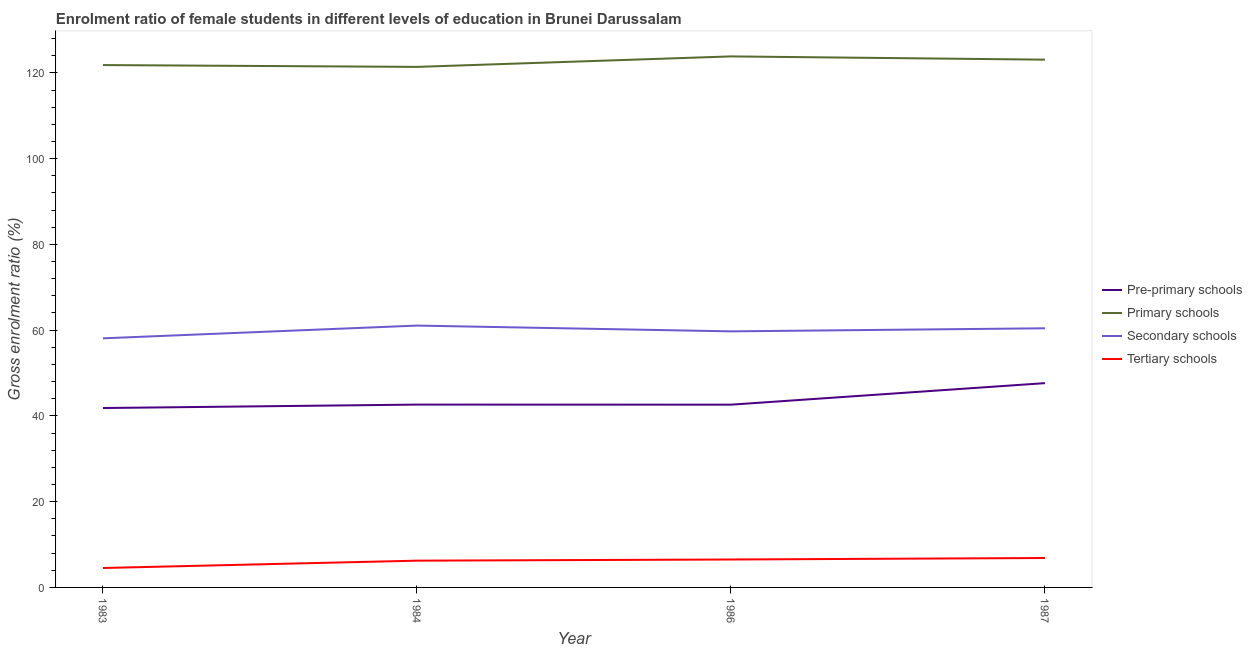What is the gross enrolment ratio(male) in tertiary schools in 1984?
Offer a terse response. 6.24. Across all years, what is the maximum gross enrolment ratio(male) in secondary schools?
Your response must be concise. 61.07. Across all years, what is the minimum gross enrolment ratio(male) in tertiary schools?
Your response must be concise. 4.53. In which year was the gross enrolment ratio(male) in tertiary schools minimum?
Your response must be concise. 1983. What is the total gross enrolment ratio(male) in pre-primary schools in the graph?
Offer a very short reply. 174.74. What is the difference between the gross enrolment ratio(male) in pre-primary schools in 1983 and that in 1986?
Your answer should be compact. -0.78. What is the difference between the gross enrolment ratio(male) in pre-primary schools in 1986 and the gross enrolment ratio(male) in tertiary schools in 1987?
Provide a succinct answer. 35.76. What is the average gross enrolment ratio(male) in pre-primary schools per year?
Ensure brevity in your answer.  43.68. In the year 1986, what is the difference between the gross enrolment ratio(male) in primary schools and gross enrolment ratio(male) in secondary schools?
Make the answer very short. 64.12. What is the ratio of the gross enrolment ratio(male) in secondary schools in 1983 to that in 1984?
Your answer should be compact. 0.95. Is the gross enrolment ratio(male) in tertiary schools in 1984 less than that in 1987?
Offer a very short reply. Yes. Is the difference between the gross enrolment ratio(male) in tertiary schools in 1984 and 1987 greater than the difference between the gross enrolment ratio(male) in pre-primary schools in 1984 and 1987?
Provide a succinct answer. Yes. What is the difference between the highest and the second highest gross enrolment ratio(male) in primary schools?
Provide a short and direct response. 0.76. What is the difference between the highest and the lowest gross enrolment ratio(male) in primary schools?
Your answer should be very brief. 2.45. In how many years, is the gross enrolment ratio(male) in pre-primary schools greater than the average gross enrolment ratio(male) in pre-primary schools taken over all years?
Offer a very short reply. 1. Is it the case that in every year, the sum of the gross enrolment ratio(male) in tertiary schools and gross enrolment ratio(male) in pre-primary schools is greater than the sum of gross enrolment ratio(male) in primary schools and gross enrolment ratio(male) in secondary schools?
Make the answer very short. No. Is the gross enrolment ratio(male) in secondary schools strictly less than the gross enrolment ratio(male) in tertiary schools over the years?
Your response must be concise. No. How many lines are there?
Provide a succinct answer. 4. How many years are there in the graph?
Provide a short and direct response. 4. What is the difference between two consecutive major ticks on the Y-axis?
Your answer should be very brief. 20. Does the graph contain any zero values?
Your answer should be compact. No. Does the graph contain grids?
Make the answer very short. No. How many legend labels are there?
Make the answer very short. 4. How are the legend labels stacked?
Your response must be concise. Vertical. What is the title of the graph?
Offer a very short reply. Enrolment ratio of female students in different levels of education in Brunei Darussalam. What is the label or title of the Y-axis?
Provide a short and direct response. Gross enrolment ratio (%). What is the Gross enrolment ratio (%) in Pre-primary schools in 1983?
Give a very brief answer. 41.84. What is the Gross enrolment ratio (%) of Primary schools in 1983?
Give a very brief answer. 121.82. What is the Gross enrolment ratio (%) in Secondary schools in 1983?
Provide a succinct answer. 58.09. What is the Gross enrolment ratio (%) of Tertiary schools in 1983?
Your answer should be compact. 4.53. What is the Gross enrolment ratio (%) in Pre-primary schools in 1984?
Make the answer very short. 42.64. What is the Gross enrolment ratio (%) of Primary schools in 1984?
Your answer should be very brief. 121.4. What is the Gross enrolment ratio (%) of Secondary schools in 1984?
Provide a succinct answer. 61.07. What is the Gross enrolment ratio (%) of Tertiary schools in 1984?
Offer a terse response. 6.24. What is the Gross enrolment ratio (%) in Pre-primary schools in 1986?
Provide a succinct answer. 42.62. What is the Gross enrolment ratio (%) in Primary schools in 1986?
Give a very brief answer. 123.84. What is the Gross enrolment ratio (%) of Secondary schools in 1986?
Give a very brief answer. 59.72. What is the Gross enrolment ratio (%) in Tertiary schools in 1986?
Provide a succinct answer. 6.51. What is the Gross enrolment ratio (%) in Pre-primary schools in 1987?
Offer a terse response. 47.64. What is the Gross enrolment ratio (%) in Primary schools in 1987?
Make the answer very short. 123.08. What is the Gross enrolment ratio (%) of Secondary schools in 1987?
Give a very brief answer. 60.43. What is the Gross enrolment ratio (%) of Tertiary schools in 1987?
Offer a very short reply. 6.86. Across all years, what is the maximum Gross enrolment ratio (%) in Pre-primary schools?
Keep it short and to the point. 47.64. Across all years, what is the maximum Gross enrolment ratio (%) in Primary schools?
Keep it short and to the point. 123.84. Across all years, what is the maximum Gross enrolment ratio (%) of Secondary schools?
Keep it short and to the point. 61.07. Across all years, what is the maximum Gross enrolment ratio (%) in Tertiary schools?
Make the answer very short. 6.86. Across all years, what is the minimum Gross enrolment ratio (%) in Pre-primary schools?
Offer a terse response. 41.84. Across all years, what is the minimum Gross enrolment ratio (%) in Primary schools?
Make the answer very short. 121.4. Across all years, what is the minimum Gross enrolment ratio (%) in Secondary schools?
Give a very brief answer. 58.09. Across all years, what is the minimum Gross enrolment ratio (%) in Tertiary schools?
Your answer should be compact. 4.53. What is the total Gross enrolment ratio (%) in Pre-primary schools in the graph?
Offer a terse response. 174.74. What is the total Gross enrolment ratio (%) in Primary schools in the graph?
Give a very brief answer. 490.14. What is the total Gross enrolment ratio (%) in Secondary schools in the graph?
Make the answer very short. 239.31. What is the total Gross enrolment ratio (%) in Tertiary schools in the graph?
Offer a terse response. 24.15. What is the difference between the Gross enrolment ratio (%) in Pre-primary schools in 1983 and that in 1984?
Ensure brevity in your answer.  -0.8. What is the difference between the Gross enrolment ratio (%) in Primary schools in 1983 and that in 1984?
Ensure brevity in your answer.  0.43. What is the difference between the Gross enrolment ratio (%) in Secondary schools in 1983 and that in 1984?
Keep it short and to the point. -2.98. What is the difference between the Gross enrolment ratio (%) in Tertiary schools in 1983 and that in 1984?
Your answer should be very brief. -1.71. What is the difference between the Gross enrolment ratio (%) in Pre-primary schools in 1983 and that in 1986?
Keep it short and to the point. -0.78. What is the difference between the Gross enrolment ratio (%) in Primary schools in 1983 and that in 1986?
Keep it short and to the point. -2.02. What is the difference between the Gross enrolment ratio (%) of Secondary schools in 1983 and that in 1986?
Provide a succinct answer. -1.63. What is the difference between the Gross enrolment ratio (%) of Tertiary schools in 1983 and that in 1986?
Your answer should be compact. -1.99. What is the difference between the Gross enrolment ratio (%) in Pre-primary schools in 1983 and that in 1987?
Your response must be concise. -5.8. What is the difference between the Gross enrolment ratio (%) of Primary schools in 1983 and that in 1987?
Ensure brevity in your answer.  -1.26. What is the difference between the Gross enrolment ratio (%) in Secondary schools in 1983 and that in 1987?
Make the answer very short. -2.34. What is the difference between the Gross enrolment ratio (%) in Tertiary schools in 1983 and that in 1987?
Your response must be concise. -2.33. What is the difference between the Gross enrolment ratio (%) of Pre-primary schools in 1984 and that in 1986?
Offer a terse response. 0.02. What is the difference between the Gross enrolment ratio (%) of Primary schools in 1984 and that in 1986?
Ensure brevity in your answer.  -2.45. What is the difference between the Gross enrolment ratio (%) of Secondary schools in 1984 and that in 1986?
Offer a very short reply. 1.35. What is the difference between the Gross enrolment ratio (%) in Tertiary schools in 1984 and that in 1986?
Your answer should be compact. -0.27. What is the difference between the Gross enrolment ratio (%) in Pre-primary schools in 1984 and that in 1987?
Provide a short and direct response. -5. What is the difference between the Gross enrolment ratio (%) in Primary schools in 1984 and that in 1987?
Your answer should be compact. -1.69. What is the difference between the Gross enrolment ratio (%) of Secondary schools in 1984 and that in 1987?
Ensure brevity in your answer.  0.63. What is the difference between the Gross enrolment ratio (%) in Tertiary schools in 1984 and that in 1987?
Your response must be concise. -0.62. What is the difference between the Gross enrolment ratio (%) of Pre-primary schools in 1986 and that in 1987?
Offer a very short reply. -5.02. What is the difference between the Gross enrolment ratio (%) in Primary schools in 1986 and that in 1987?
Make the answer very short. 0.76. What is the difference between the Gross enrolment ratio (%) in Secondary schools in 1986 and that in 1987?
Your answer should be very brief. -0.72. What is the difference between the Gross enrolment ratio (%) in Tertiary schools in 1986 and that in 1987?
Your answer should be compact. -0.35. What is the difference between the Gross enrolment ratio (%) in Pre-primary schools in 1983 and the Gross enrolment ratio (%) in Primary schools in 1984?
Ensure brevity in your answer.  -79.56. What is the difference between the Gross enrolment ratio (%) in Pre-primary schools in 1983 and the Gross enrolment ratio (%) in Secondary schools in 1984?
Give a very brief answer. -19.23. What is the difference between the Gross enrolment ratio (%) in Pre-primary schools in 1983 and the Gross enrolment ratio (%) in Tertiary schools in 1984?
Ensure brevity in your answer.  35.59. What is the difference between the Gross enrolment ratio (%) in Primary schools in 1983 and the Gross enrolment ratio (%) in Secondary schools in 1984?
Give a very brief answer. 60.76. What is the difference between the Gross enrolment ratio (%) in Primary schools in 1983 and the Gross enrolment ratio (%) in Tertiary schools in 1984?
Keep it short and to the point. 115.58. What is the difference between the Gross enrolment ratio (%) of Secondary schools in 1983 and the Gross enrolment ratio (%) of Tertiary schools in 1984?
Offer a very short reply. 51.85. What is the difference between the Gross enrolment ratio (%) of Pre-primary schools in 1983 and the Gross enrolment ratio (%) of Primary schools in 1986?
Make the answer very short. -82. What is the difference between the Gross enrolment ratio (%) in Pre-primary schools in 1983 and the Gross enrolment ratio (%) in Secondary schools in 1986?
Offer a terse response. -17.88. What is the difference between the Gross enrolment ratio (%) in Pre-primary schools in 1983 and the Gross enrolment ratio (%) in Tertiary schools in 1986?
Your response must be concise. 35.32. What is the difference between the Gross enrolment ratio (%) of Primary schools in 1983 and the Gross enrolment ratio (%) of Secondary schools in 1986?
Give a very brief answer. 62.1. What is the difference between the Gross enrolment ratio (%) of Primary schools in 1983 and the Gross enrolment ratio (%) of Tertiary schools in 1986?
Your answer should be compact. 115.31. What is the difference between the Gross enrolment ratio (%) of Secondary schools in 1983 and the Gross enrolment ratio (%) of Tertiary schools in 1986?
Offer a terse response. 51.58. What is the difference between the Gross enrolment ratio (%) of Pre-primary schools in 1983 and the Gross enrolment ratio (%) of Primary schools in 1987?
Your answer should be very brief. -81.25. What is the difference between the Gross enrolment ratio (%) in Pre-primary schools in 1983 and the Gross enrolment ratio (%) in Secondary schools in 1987?
Give a very brief answer. -18.6. What is the difference between the Gross enrolment ratio (%) in Pre-primary schools in 1983 and the Gross enrolment ratio (%) in Tertiary schools in 1987?
Ensure brevity in your answer.  34.98. What is the difference between the Gross enrolment ratio (%) in Primary schools in 1983 and the Gross enrolment ratio (%) in Secondary schools in 1987?
Make the answer very short. 61.39. What is the difference between the Gross enrolment ratio (%) in Primary schools in 1983 and the Gross enrolment ratio (%) in Tertiary schools in 1987?
Give a very brief answer. 114.96. What is the difference between the Gross enrolment ratio (%) of Secondary schools in 1983 and the Gross enrolment ratio (%) of Tertiary schools in 1987?
Your answer should be compact. 51.23. What is the difference between the Gross enrolment ratio (%) of Pre-primary schools in 1984 and the Gross enrolment ratio (%) of Primary schools in 1986?
Offer a terse response. -81.2. What is the difference between the Gross enrolment ratio (%) of Pre-primary schools in 1984 and the Gross enrolment ratio (%) of Secondary schools in 1986?
Provide a succinct answer. -17.08. What is the difference between the Gross enrolment ratio (%) of Pre-primary schools in 1984 and the Gross enrolment ratio (%) of Tertiary schools in 1986?
Keep it short and to the point. 36.13. What is the difference between the Gross enrolment ratio (%) in Primary schools in 1984 and the Gross enrolment ratio (%) in Secondary schools in 1986?
Your answer should be very brief. 61.68. What is the difference between the Gross enrolment ratio (%) in Primary schools in 1984 and the Gross enrolment ratio (%) in Tertiary schools in 1986?
Keep it short and to the point. 114.88. What is the difference between the Gross enrolment ratio (%) in Secondary schools in 1984 and the Gross enrolment ratio (%) in Tertiary schools in 1986?
Ensure brevity in your answer.  54.55. What is the difference between the Gross enrolment ratio (%) of Pre-primary schools in 1984 and the Gross enrolment ratio (%) of Primary schools in 1987?
Ensure brevity in your answer.  -80.44. What is the difference between the Gross enrolment ratio (%) of Pre-primary schools in 1984 and the Gross enrolment ratio (%) of Secondary schools in 1987?
Offer a terse response. -17.79. What is the difference between the Gross enrolment ratio (%) of Pre-primary schools in 1984 and the Gross enrolment ratio (%) of Tertiary schools in 1987?
Your answer should be very brief. 35.78. What is the difference between the Gross enrolment ratio (%) in Primary schools in 1984 and the Gross enrolment ratio (%) in Secondary schools in 1987?
Ensure brevity in your answer.  60.96. What is the difference between the Gross enrolment ratio (%) in Primary schools in 1984 and the Gross enrolment ratio (%) in Tertiary schools in 1987?
Provide a succinct answer. 114.53. What is the difference between the Gross enrolment ratio (%) in Secondary schools in 1984 and the Gross enrolment ratio (%) in Tertiary schools in 1987?
Your response must be concise. 54.21. What is the difference between the Gross enrolment ratio (%) of Pre-primary schools in 1986 and the Gross enrolment ratio (%) of Primary schools in 1987?
Give a very brief answer. -80.46. What is the difference between the Gross enrolment ratio (%) of Pre-primary schools in 1986 and the Gross enrolment ratio (%) of Secondary schools in 1987?
Your answer should be very brief. -17.82. What is the difference between the Gross enrolment ratio (%) of Pre-primary schools in 1986 and the Gross enrolment ratio (%) of Tertiary schools in 1987?
Provide a short and direct response. 35.76. What is the difference between the Gross enrolment ratio (%) of Primary schools in 1986 and the Gross enrolment ratio (%) of Secondary schools in 1987?
Provide a short and direct response. 63.41. What is the difference between the Gross enrolment ratio (%) of Primary schools in 1986 and the Gross enrolment ratio (%) of Tertiary schools in 1987?
Offer a very short reply. 116.98. What is the difference between the Gross enrolment ratio (%) of Secondary schools in 1986 and the Gross enrolment ratio (%) of Tertiary schools in 1987?
Keep it short and to the point. 52.86. What is the average Gross enrolment ratio (%) of Pre-primary schools per year?
Your answer should be compact. 43.68. What is the average Gross enrolment ratio (%) in Primary schools per year?
Provide a short and direct response. 122.54. What is the average Gross enrolment ratio (%) of Secondary schools per year?
Offer a terse response. 59.83. What is the average Gross enrolment ratio (%) of Tertiary schools per year?
Give a very brief answer. 6.04. In the year 1983, what is the difference between the Gross enrolment ratio (%) of Pre-primary schools and Gross enrolment ratio (%) of Primary schools?
Make the answer very short. -79.99. In the year 1983, what is the difference between the Gross enrolment ratio (%) of Pre-primary schools and Gross enrolment ratio (%) of Secondary schools?
Make the answer very short. -16.26. In the year 1983, what is the difference between the Gross enrolment ratio (%) of Pre-primary schools and Gross enrolment ratio (%) of Tertiary schools?
Keep it short and to the point. 37.31. In the year 1983, what is the difference between the Gross enrolment ratio (%) of Primary schools and Gross enrolment ratio (%) of Secondary schools?
Make the answer very short. 63.73. In the year 1983, what is the difference between the Gross enrolment ratio (%) in Primary schools and Gross enrolment ratio (%) in Tertiary schools?
Your response must be concise. 117.29. In the year 1983, what is the difference between the Gross enrolment ratio (%) of Secondary schools and Gross enrolment ratio (%) of Tertiary schools?
Your answer should be very brief. 53.56. In the year 1984, what is the difference between the Gross enrolment ratio (%) of Pre-primary schools and Gross enrolment ratio (%) of Primary schools?
Provide a short and direct response. -78.76. In the year 1984, what is the difference between the Gross enrolment ratio (%) in Pre-primary schools and Gross enrolment ratio (%) in Secondary schools?
Provide a short and direct response. -18.43. In the year 1984, what is the difference between the Gross enrolment ratio (%) of Pre-primary schools and Gross enrolment ratio (%) of Tertiary schools?
Ensure brevity in your answer.  36.4. In the year 1984, what is the difference between the Gross enrolment ratio (%) of Primary schools and Gross enrolment ratio (%) of Secondary schools?
Offer a terse response. 60.33. In the year 1984, what is the difference between the Gross enrolment ratio (%) in Primary schools and Gross enrolment ratio (%) in Tertiary schools?
Your answer should be compact. 115.15. In the year 1984, what is the difference between the Gross enrolment ratio (%) in Secondary schools and Gross enrolment ratio (%) in Tertiary schools?
Provide a short and direct response. 54.82. In the year 1986, what is the difference between the Gross enrolment ratio (%) of Pre-primary schools and Gross enrolment ratio (%) of Primary schools?
Provide a succinct answer. -81.22. In the year 1986, what is the difference between the Gross enrolment ratio (%) in Pre-primary schools and Gross enrolment ratio (%) in Secondary schools?
Keep it short and to the point. -17.1. In the year 1986, what is the difference between the Gross enrolment ratio (%) in Pre-primary schools and Gross enrolment ratio (%) in Tertiary schools?
Provide a succinct answer. 36.11. In the year 1986, what is the difference between the Gross enrolment ratio (%) of Primary schools and Gross enrolment ratio (%) of Secondary schools?
Provide a short and direct response. 64.12. In the year 1986, what is the difference between the Gross enrolment ratio (%) in Primary schools and Gross enrolment ratio (%) in Tertiary schools?
Provide a short and direct response. 117.33. In the year 1986, what is the difference between the Gross enrolment ratio (%) of Secondary schools and Gross enrolment ratio (%) of Tertiary schools?
Your response must be concise. 53.2. In the year 1987, what is the difference between the Gross enrolment ratio (%) in Pre-primary schools and Gross enrolment ratio (%) in Primary schools?
Your answer should be compact. -75.44. In the year 1987, what is the difference between the Gross enrolment ratio (%) in Pre-primary schools and Gross enrolment ratio (%) in Secondary schools?
Keep it short and to the point. -12.79. In the year 1987, what is the difference between the Gross enrolment ratio (%) of Pre-primary schools and Gross enrolment ratio (%) of Tertiary schools?
Your answer should be compact. 40.78. In the year 1987, what is the difference between the Gross enrolment ratio (%) of Primary schools and Gross enrolment ratio (%) of Secondary schools?
Your answer should be very brief. 62.65. In the year 1987, what is the difference between the Gross enrolment ratio (%) of Primary schools and Gross enrolment ratio (%) of Tertiary schools?
Offer a terse response. 116.22. In the year 1987, what is the difference between the Gross enrolment ratio (%) of Secondary schools and Gross enrolment ratio (%) of Tertiary schools?
Offer a very short reply. 53.57. What is the ratio of the Gross enrolment ratio (%) of Pre-primary schools in 1983 to that in 1984?
Keep it short and to the point. 0.98. What is the ratio of the Gross enrolment ratio (%) of Secondary schools in 1983 to that in 1984?
Give a very brief answer. 0.95. What is the ratio of the Gross enrolment ratio (%) of Tertiary schools in 1983 to that in 1984?
Make the answer very short. 0.73. What is the ratio of the Gross enrolment ratio (%) of Pre-primary schools in 1983 to that in 1986?
Your answer should be very brief. 0.98. What is the ratio of the Gross enrolment ratio (%) of Primary schools in 1983 to that in 1986?
Keep it short and to the point. 0.98. What is the ratio of the Gross enrolment ratio (%) in Secondary schools in 1983 to that in 1986?
Provide a succinct answer. 0.97. What is the ratio of the Gross enrolment ratio (%) in Tertiary schools in 1983 to that in 1986?
Provide a succinct answer. 0.7. What is the ratio of the Gross enrolment ratio (%) in Pre-primary schools in 1983 to that in 1987?
Make the answer very short. 0.88. What is the ratio of the Gross enrolment ratio (%) in Primary schools in 1983 to that in 1987?
Give a very brief answer. 0.99. What is the ratio of the Gross enrolment ratio (%) of Secondary schools in 1983 to that in 1987?
Offer a very short reply. 0.96. What is the ratio of the Gross enrolment ratio (%) of Tertiary schools in 1983 to that in 1987?
Your response must be concise. 0.66. What is the ratio of the Gross enrolment ratio (%) of Pre-primary schools in 1984 to that in 1986?
Ensure brevity in your answer.  1. What is the ratio of the Gross enrolment ratio (%) of Primary schools in 1984 to that in 1986?
Provide a succinct answer. 0.98. What is the ratio of the Gross enrolment ratio (%) of Secondary schools in 1984 to that in 1986?
Offer a terse response. 1.02. What is the ratio of the Gross enrolment ratio (%) in Tertiary schools in 1984 to that in 1986?
Keep it short and to the point. 0.96. What is the ratio of the Gross enrolment ratio (%) of Pre-primary schools in 1984 to that in 1987?
Keep it short and to the point. 0.9. What is the ratio of the Gross enrolment ratio (%) in Primary schools in 1984 to that in 1987?
Ensure brevity in your answer.  0.99. What is the ratio of the Gross enrolment ratio (%) of Secondary schools in 1984 to that in 1987?
Provide a short and direct response. 1.01. What is the ratio of the Gross enrolment ratio (%) in Tertiary schools in 1984 to that in 1987?
Your answer should be very brief. 0.91. What is the ratio of the Gross enrolment ratio (%) in Pre-primary schools in 1986 to that in 1987?
Offer a terse response. 0.89. What is the ratio of the Gross enrolment ratio (%) in Primary schools in 1986 to that in 1987?
Your answer should be very brief. 1.01. What is the ratio of the Gross enrolment ratio (%) in Tertiary schools in 1986 to that in 1987?
Your answer should be very brief. 0.95. What is the difference between the highest and the second highest Gross enrolment ratio (%) of Pre-primary schools?
Offer a terse response. 5. What is the difference between the highest and the second highest Gross enrolment ratio (%) of Primary schools?
Your answer should be compact. 0.76. What is the difference between the highest and the second highest Gross enrolment ratio (%) in Secondary schools?
Your response must be concise. 0.63. What is the difference between the highest and the second highest Gross enrolment ratio (%) of Tertiary schools?
Keep it short and to the point. 0.35. What is the difference between the highest and the lowest Gross enrolment ratio (%) in Pre-primary schools?
Offer a very short reply. 5.8. What is the difference between the highest and the lowest Gross enrolment ratio (%) of Primary schools?
Your answer should be compact. 2.45. What is the difference between the highest and the lowest Gross enrolment ratio (%) of Secondary schools?
Your answer should be compact. 2.98. What is the difference between the highest and the lowest Gross enrolment ratio (%) of Tertiary schools?
Make the answer very short. 2.33. 